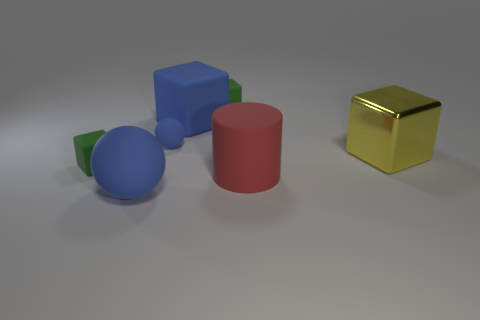Subtract all blue blocks. How many blocks are left? 3 Subtract all green blocks. How many blocks are left? 2 Subtract 2 blocks. How many blocks are left? 2 Add 1 large cyan rubber objects. How many objects exist? 8 Subtract 0 brown cubes. How many objects are left? 7 Subtract all cylinders. How many objects are left? 6 Subtract all red cubes. Subtract all brown balls. How many cubes are left? 4 Subtract all cyan cylinders. How many green cubes are left? 2 Subtract all yellow cylinders. Subtract all blue matte blocks. How many objects are left? 6 Add 2 small spheres. How many small spheres are left? 3 